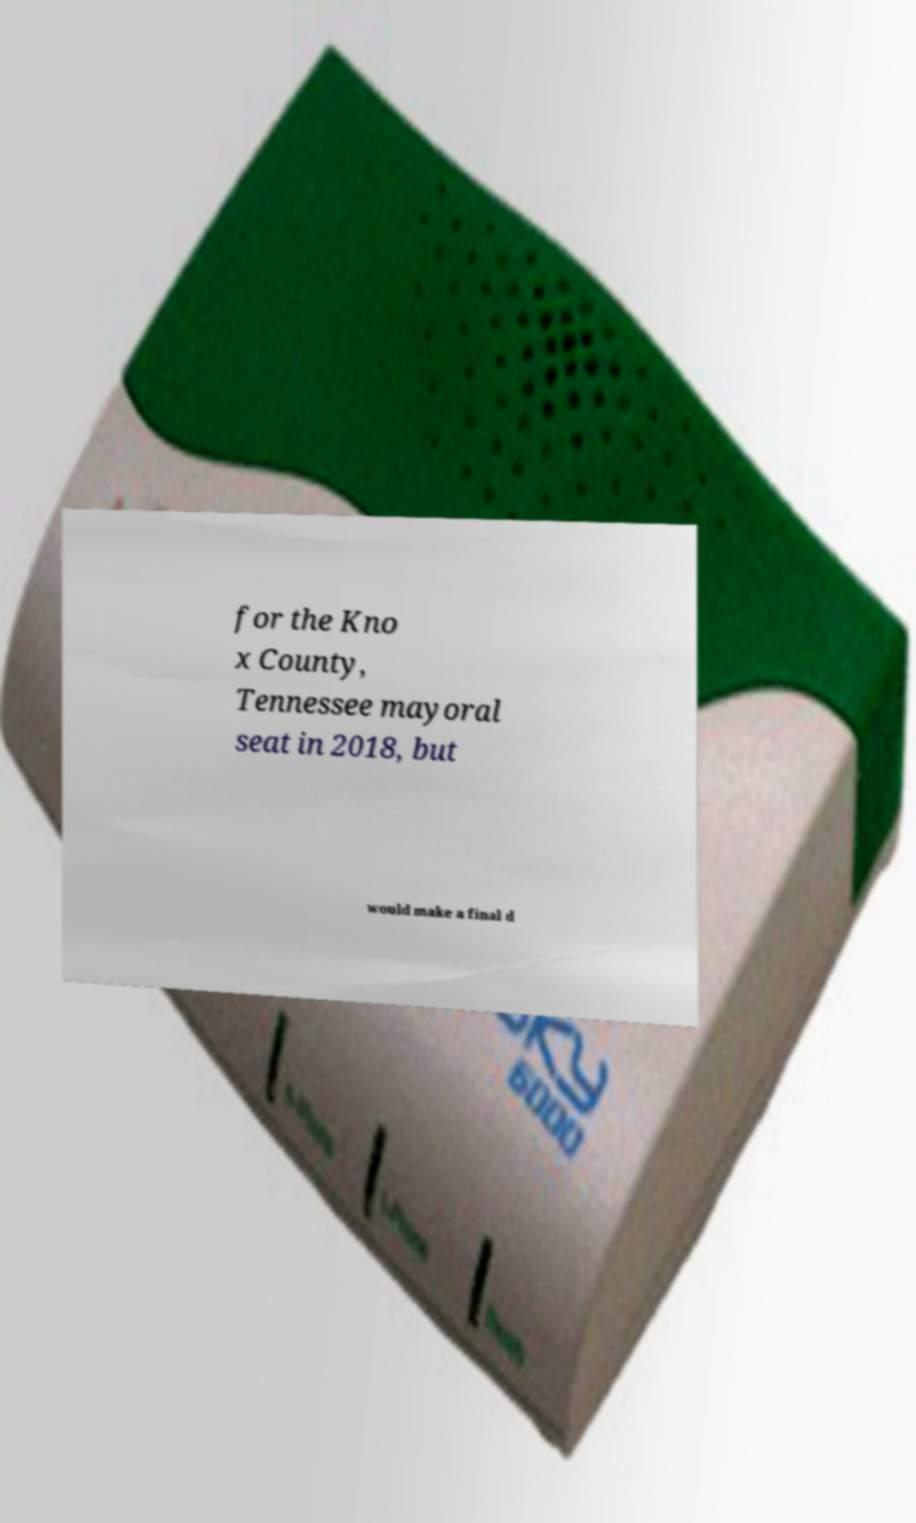Please identify and transcribe the text found in this image. for the Kno x County, Tennessee mayoral seat in 2018, but would make a final d 